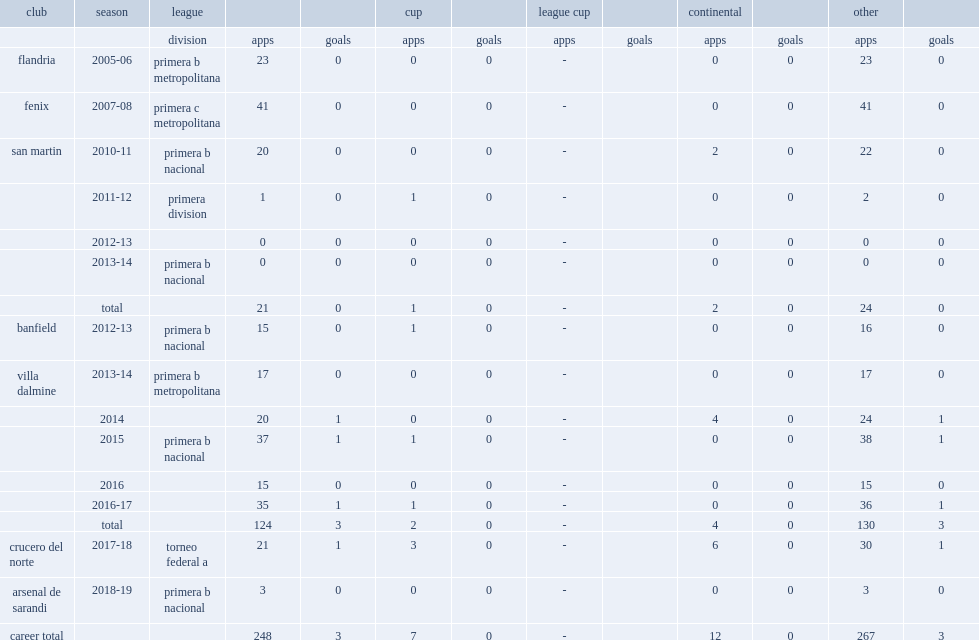In 2014, which club in primera b metropolitana did zamponi join? Villa dalmine. Could you parse the entire table as a dict? {'header': ['club', 'season', 'league', '', '', 'cup', '', 'league cup', '', 'continental', '', 'other', ''], 'rows': [['', '', 'division', 'apps', 'goals', 'apps', 'goals', 'apps', 'goals', 'apps', 'goals', 'apps', 'goals'], ['flandria', '2005-06', 'primera b metropolitana', '23', '0', '0', '0', '-', '', '0', '0', '23', '0'], ['fenix', '2007-08', 'primera c metropolitana', '41', '0', '0', '0', '-', '', '0', '0', '41', '0'], ['san martin', '2010-11', 'primera b nacional', '20', '0', '0', '0', '-', '', '2', '0', '22', '0'], ['', '2011-12', 'primera division', '1', '0', '1', '0', '-', '', '0', '0', '2', '0'], ['', '2012-13', '', '0', '0', '0', '0', '-', '', '0', '0', '0', '0'], ['', '2013-14', 'primera b nacional', '0', '0', '0', '0', '-', '', '0', '0', '0', '0'], ['', 'total', '', '21', '0', '1', '0', '-', '', '2', '0', '24', '0'], ['banfield', '2012-13', 'primera b nacional', '15', '0', '1', '0', '-', '', '0', '0', '16', '0'], ['villa dalmine', '2013-14', 'primera b metropolitana', '17', '0', '0', '0', '-', '', '0', '0', '17', '0'], ['', '2014', '', '20', '1', '0', '0', '-', '', '4', '0', '24', '1'], ['', '2015', 'primera b nacional', '37', '1', '1', '0', '-', '', '0', '0', '38', '1'], ['', '2016', '', '15', '0', '0', '0', '-', '', '0', '0', '15', '0'], ['', '2016-17', '', '35', '1', '1', '0', '-', '', '0', '0', '36', '1'], ['', 'total', '', '124', '3', '2', '0', '-', '', '4', '0', '130', '3'], ['crucero del norte', '2017-18', 'torneo federal a', '21', '1', '3', '0', '-', '', '6', '0', '30', '1'], ['arsenal de sarandi', '2018-19', 'primera b nacional', '3', '0', '0', '0', '-', '', '0', '0', '3', '0'], ['career total', '', '', '248', '3', '7', '0', '-', '', '12', '0', '267', '3']]} 